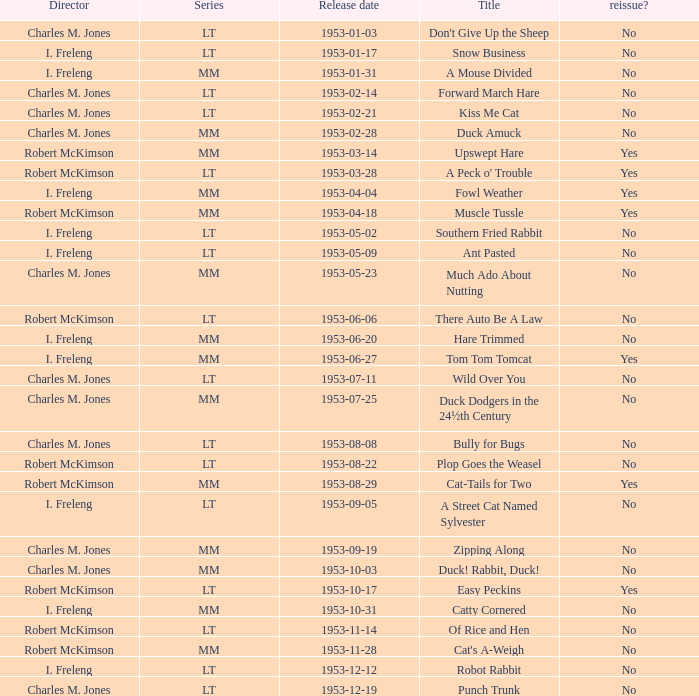Was there a reissue of the film released on 1953-10-03? No. 